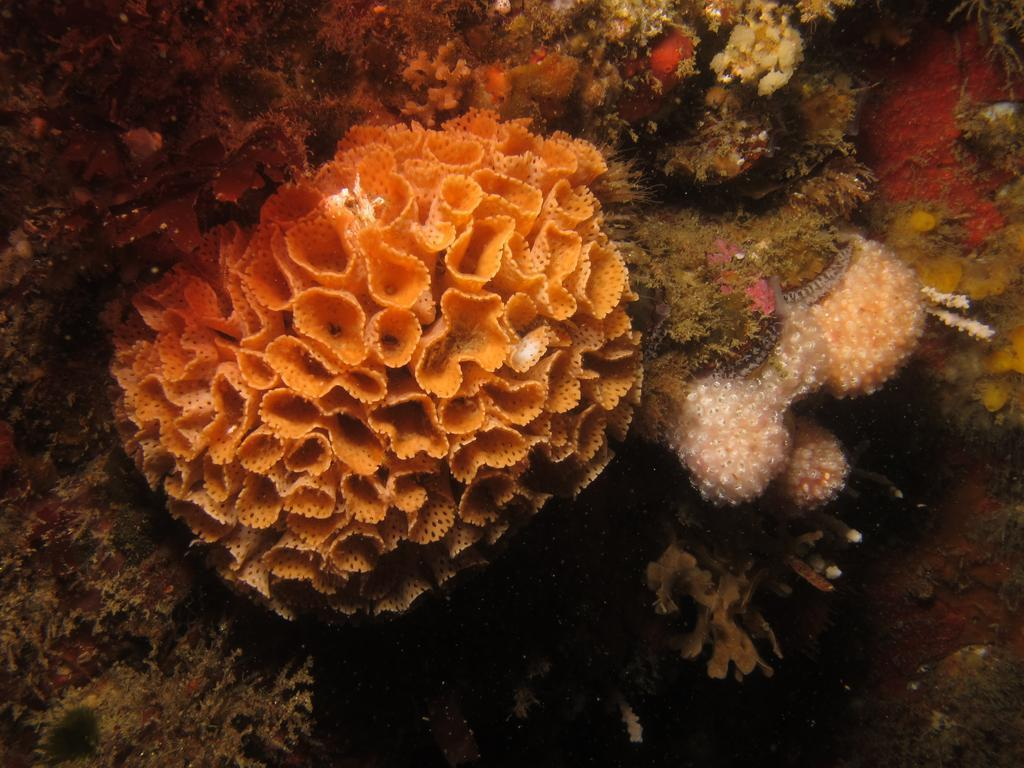What type of underwater structures can be seen in the image? There are corals visible in the water in the image. What type of writing can be seen on the volcano in the image? There is no volcano present in the image, and therefore no writing can be seen on it. How many brothers can be seen playing near the corals in the image? There is no reference to any brothers in the image, and the image only features corals visible in the water. 